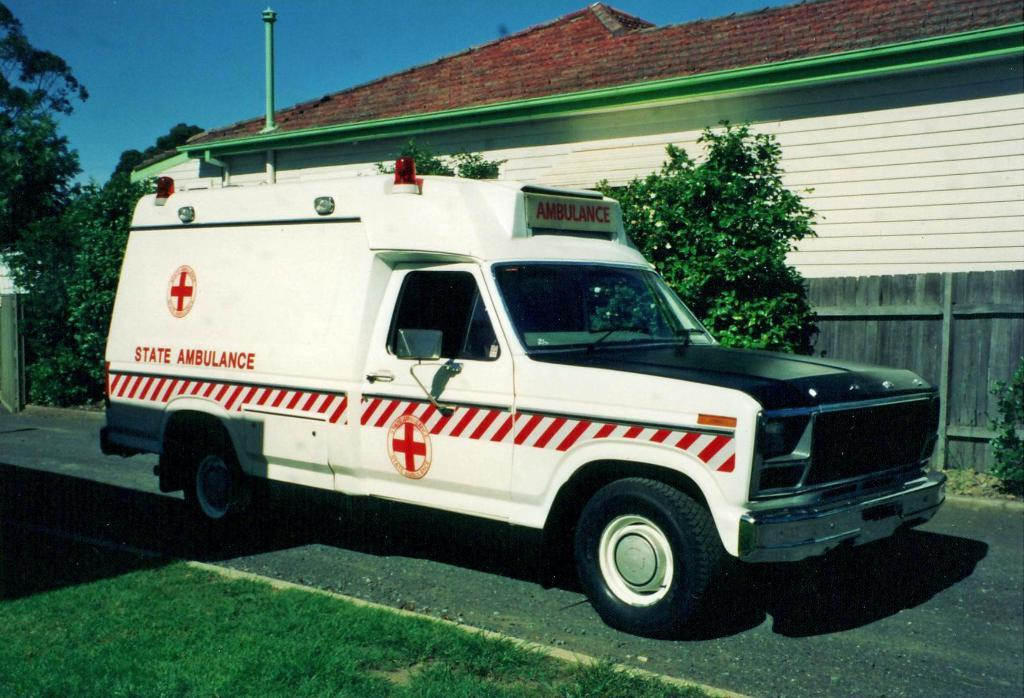What is the main subject in the center of the image? There is a vehicle on the road in the center of the image. What can be seen in the background of the image? There are trees, a building, and a pole in the background of the image. What is visible at the top of the image? The sky is visible at the top of the image. What type of game is being played in the hall in the image? There is no hall or game present in the image; it features a vehicle on the road with a background of trees, a building, and a pole. What industry is depicted in the image? The image does not depict any specific industry; it shows a vehicle on the road with a background of trees, a building, and a pole. 